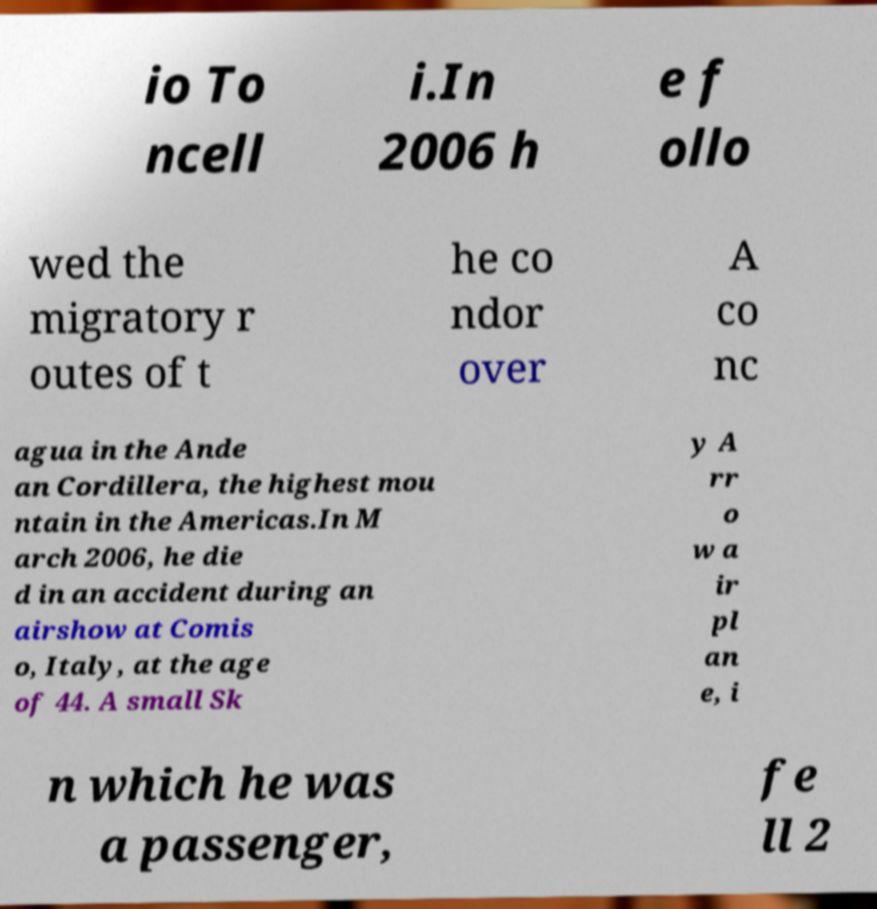There's text embedded in this image that I need extracted. Can you transcribe it verbatim? io To ncell i.In 2006 h e f ollo wed the migratory r outes of t he co ndor over A co nc agua in the Ande an Cordillera, the highest mou ntain in the Americas.In M arch 2006, he die d in an accident during an airshow at Comis o, Italy, at the age of 44. A small Sk y A rr o w a ir pl an e, i n which he was a passenger, fe ll 2 